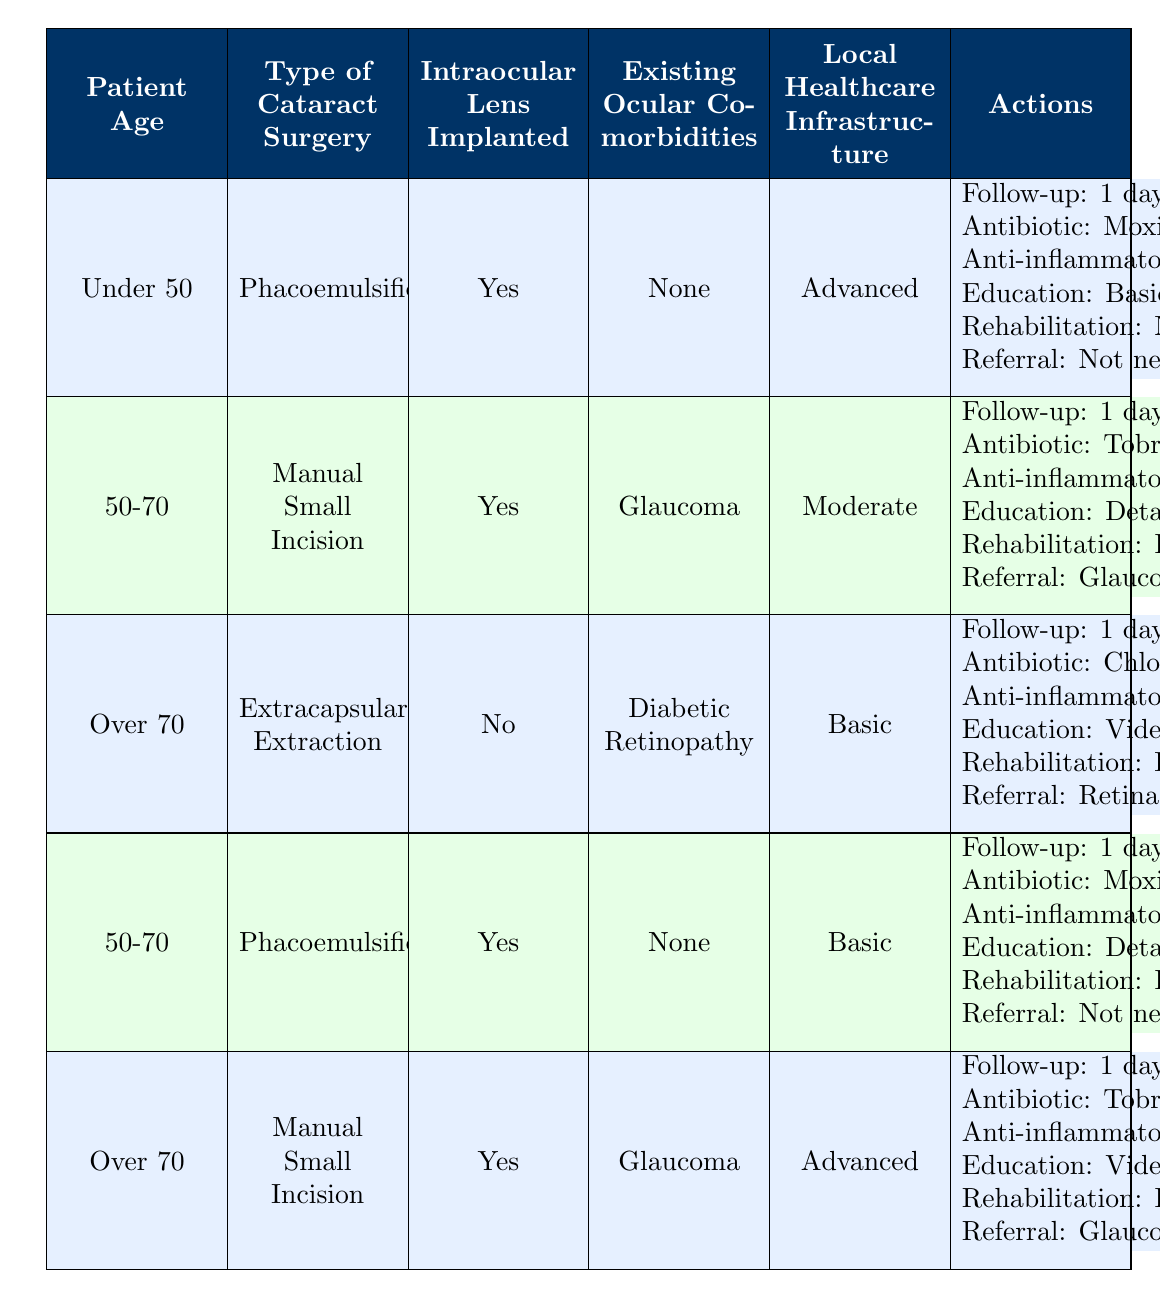What is the follow-up schedule for patients under 50 who undergo phacoemulsification surgery with an intraocular lens implanted and no ocular comorbidities in an advanced healthcare setting? The table indicates that for patients under 50 who have phacoemulsification surgery and meet the other specified conditions, the follow-up schedule is 1 day, 1 week, and 1 month.
Answer: 1 day, 1 week, 1 month Which antibiotic eye drops are prescribed for patients aged over 70 who have an extracapsular extraction and no intraocular lens implanted, along with diabetic retinopathy in a basic healthcare setting? According to the table, for patients over 70 with these specified conditions, the prescribed antibiotic eye drop is chloramphenicol.
Answer: Chloramphenicol Do all patients aged 50-70 with phacoemulsification receive the same follow-up schedule, regardless of their ocular comorbidities? To determine this, we check the different conditions for patients aged 50-70. There are two entries: one has a follow-up schedule of 1 day, 1 week, 1 month (with no comorbidities), and the other has 1 day, 1 week, 2 weeks, 1 month (with glaucoma). Thus, they do not all receive the same follow-up schedule.
Answer: No Which anti-inflammatory eye drops are used for patients aged 50-70 with manual small incision surgery and glaucoma in a moderate healthcare setting? The table specifies that these patients are prescribed dexamethasone as their anti-inflammatory eye drops.
Answer: Dexamethasone What percentage of patients aged over 70 receive a referral to a specialist following manual small incision surgery with glaucoma in an advanced healthcare setting? In the table, both entries for patients over 70 with manual small incision surgery detail that referral to a glaucoma specialist is needed. There are two entries with applicable demographics; thus, 100% of this subset of patients is referred according to the data.
Answer: 100% 